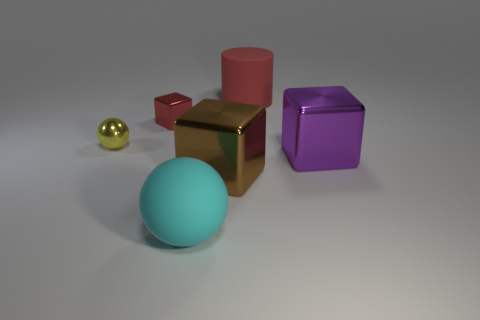Add 3 tiny metal balls. How many objects exist? 9 Subtract all big cubes. How many cubes are left? 1 Subtract all cylinders. How many objects are left? 5 Subtract all red cylinders. Subtract all metallic blocks. How many objects are left? 2 Add 4 brown shiny objects. How many brown shiny objects are left? 5 Add 3 red matte things. How many red matte things exist? 4 Subtract 0 yellow cubes. How many objects are left? 6 